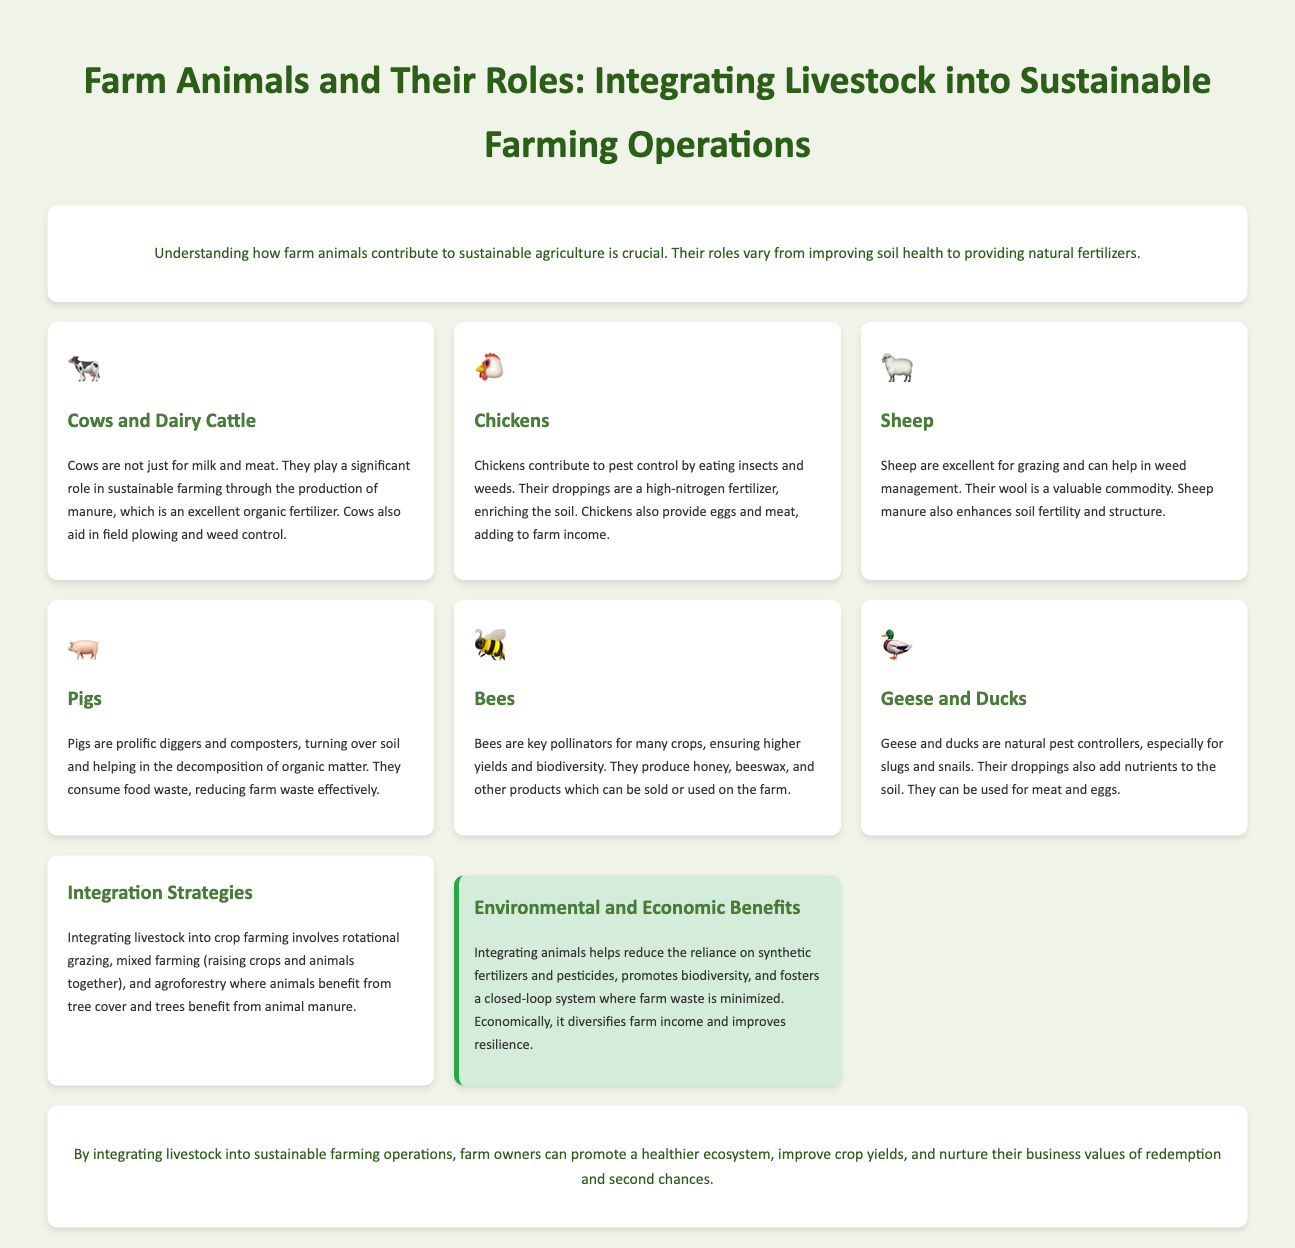What is the title of the infographic? The title is stated at the top of the document and summarizes the main topic.
Answer: Farm Animals and Their Roles: Integrating Livestock into Sustainable Farming Operations Which animal contributes to pest control by eating insects and weeds? The document specifically mentions this animal under its respective section.
Answer: Chickens What role do sheep play in sustainable farming? The document describes this role in the section dedicated to sheep, focusing on their contributions to grazing and soil fertility.
Answer: Grazing and weed management What is one integration strategy mentioned for livestock in crop farming? The document lists multiple strategies for integrating livestock and identifies one in the corresponding section.
Answer: Rotational grazing How do bees contribute to farming operations? The role of bees is detailed in the section about them, focusing on their impact on crops and products.
Answer: Pollination What type of fertilizer do cows provide? The document highlights the contribution of cows to sustainable farming through their waste product.
Answer: Organic fertilizer What is the economic benefit of integrating livestock according to the document? The document provides a summary of the benefits under a section detailing environmental and economic advantages.
Answer: Diversifies farm income Which animals are natural pest controllers mentioned in the infographic? The document specifies which animals help control pests in their respective section, pointing out their role.
Answer: Geese and ducks What is one benefit of integrating animals into farming? The benefits are outlined in a specific section of the document, focusing on both environmental and economic aspects.
Answer: Reduces reliance on synthetic fertilizers and pesticides 